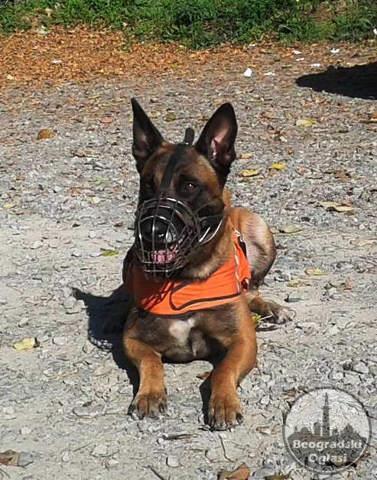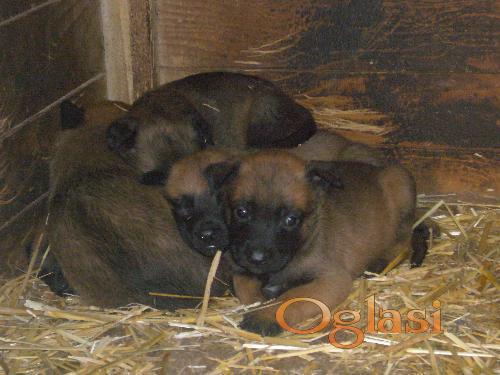The first image is the image on the left, the second image is the image on the right. Given the left and right images, does the statement "There is no more than one dog in the left image." hold true? Answer yes or no. Yes. The first image is the image on the left, the second image is the image on the right. Assess this claim about the two images: "Only german shepherd puppies are shown, and each image includes at least two puppies.". Correct or not? Answer yes or no. No. 